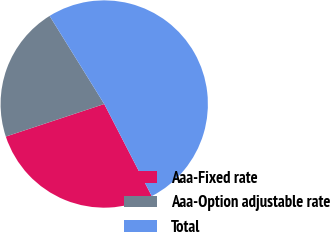Convert chart to OTSL. <chart><loc_0><loc_0><loc_500><loc_500><pie_chart><fcel>Aaa-Fixed rate<fcel>Aaa-Option adjustable rate<fcel>Total<nl><fcel>27.5%<fcel>21.25%<fcel>51.25%<nl></chart> 